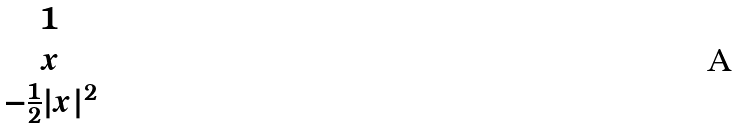Convert formula to latex. <formula><loc_0><loc_0><loc_500><loc_500>\begin{matrix} 1 \\ x \\ - \frac { 1 } { 2 } | x | ^ { 2 } \end{matrix}</formula> 